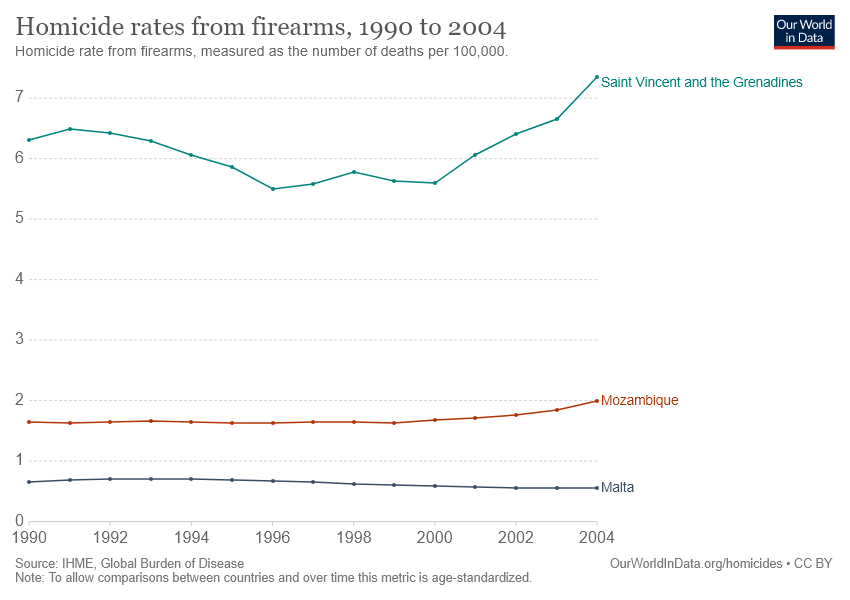List a handful of essential elements in this visual. The country represented by the red line in the given graph is Mozambique. In 2004, Saint Vincent and the Grenadines experienced the highest recorded homicide rates due to firearms. 